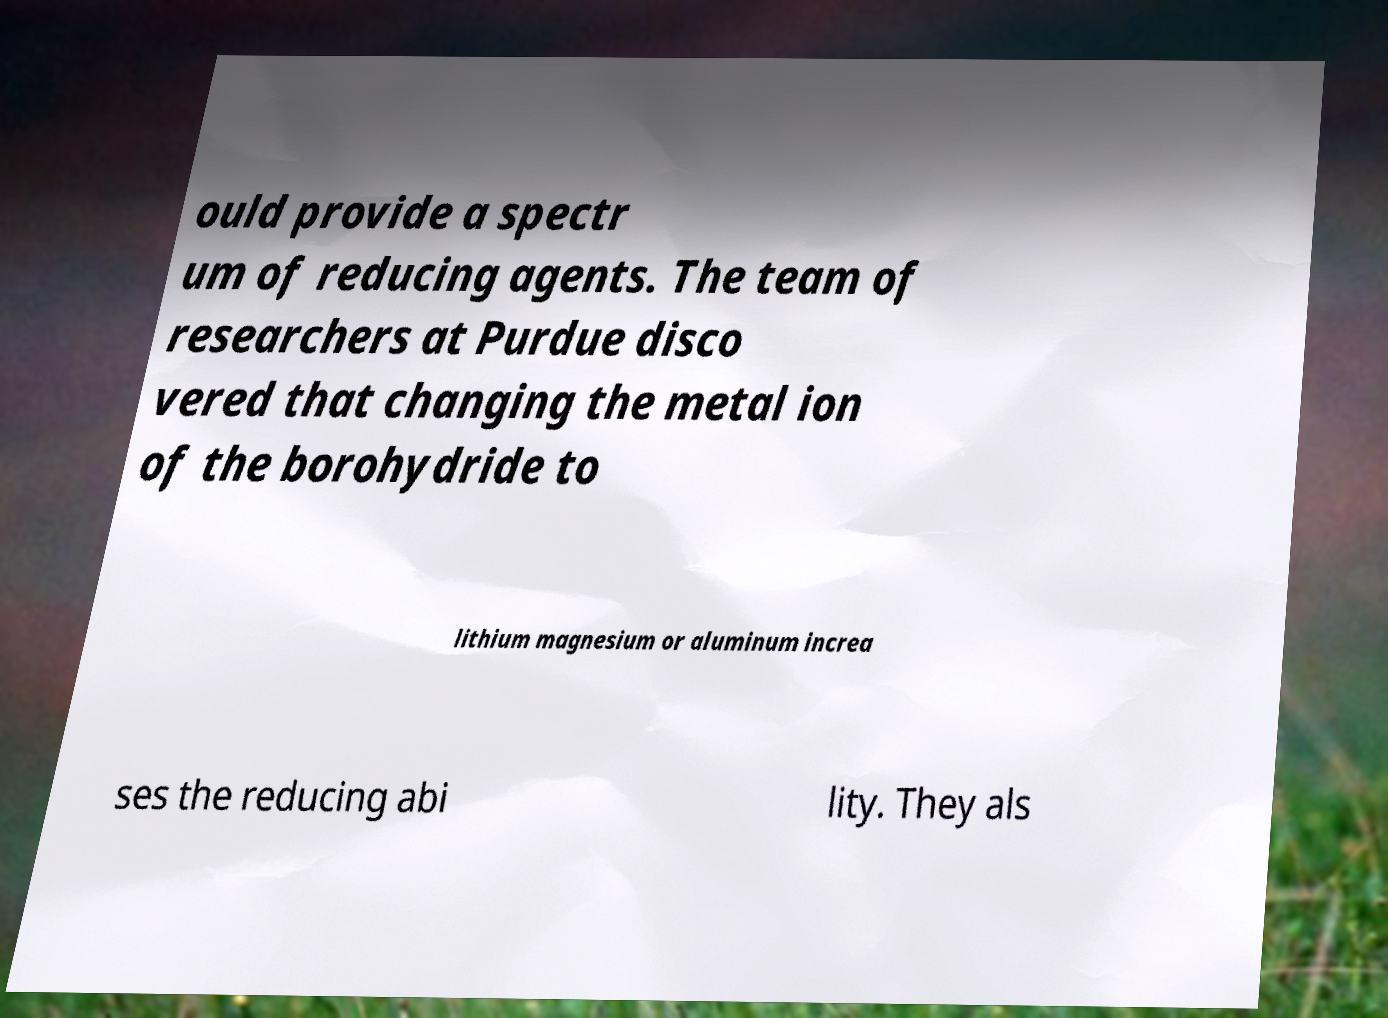There's text embedded in this image that I need extracted. Can you transcribe it verbatim? ould provide a spectr um of reducing agents. The team of researchers at Purdue disco vered that changing the metal ion of the borohydride to lithium magnesium or aluminum increa ses the reducing abi lity. They als 